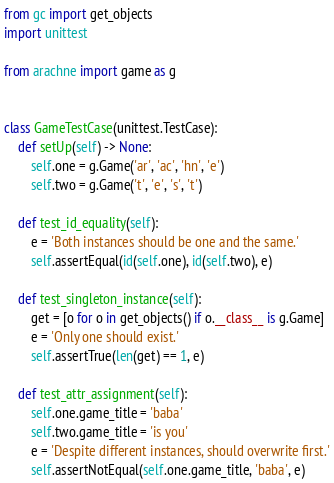Convert code to text. <code><loc_0><loc_0><loc_500><loc_500><_Python_>from gc import get_objects
import unittest

from arachne import game as g


class GameTestCase(unittest.TestCase):
    def setUp(self) -> None:
        self.one = g.Game('ar', 'ac', 'hn', 'e')
        self.two = g.Game('t', 'e', 's', 't')

    def test_id_equality(self):
        e = 'Both instances should be one and the same.'
        self.assertEqual(id(self.one), id(self.two), e)

    def test_singleton_instance(self):
        get = [o for o in get_objects() if o.__class__ is g.Game]
        e = 'Only one should exist.'
        self.assertTrue(len(get) == 1, e)

    def test_attr_assignment(self):
        self.one.game_title = 'baba'
        self.two.game_title = 'is you'
        e = 'Despite different instances, should overwrite first.'
        self.assertNotEqual(self.one.game_title, 'baba', e)</code> 